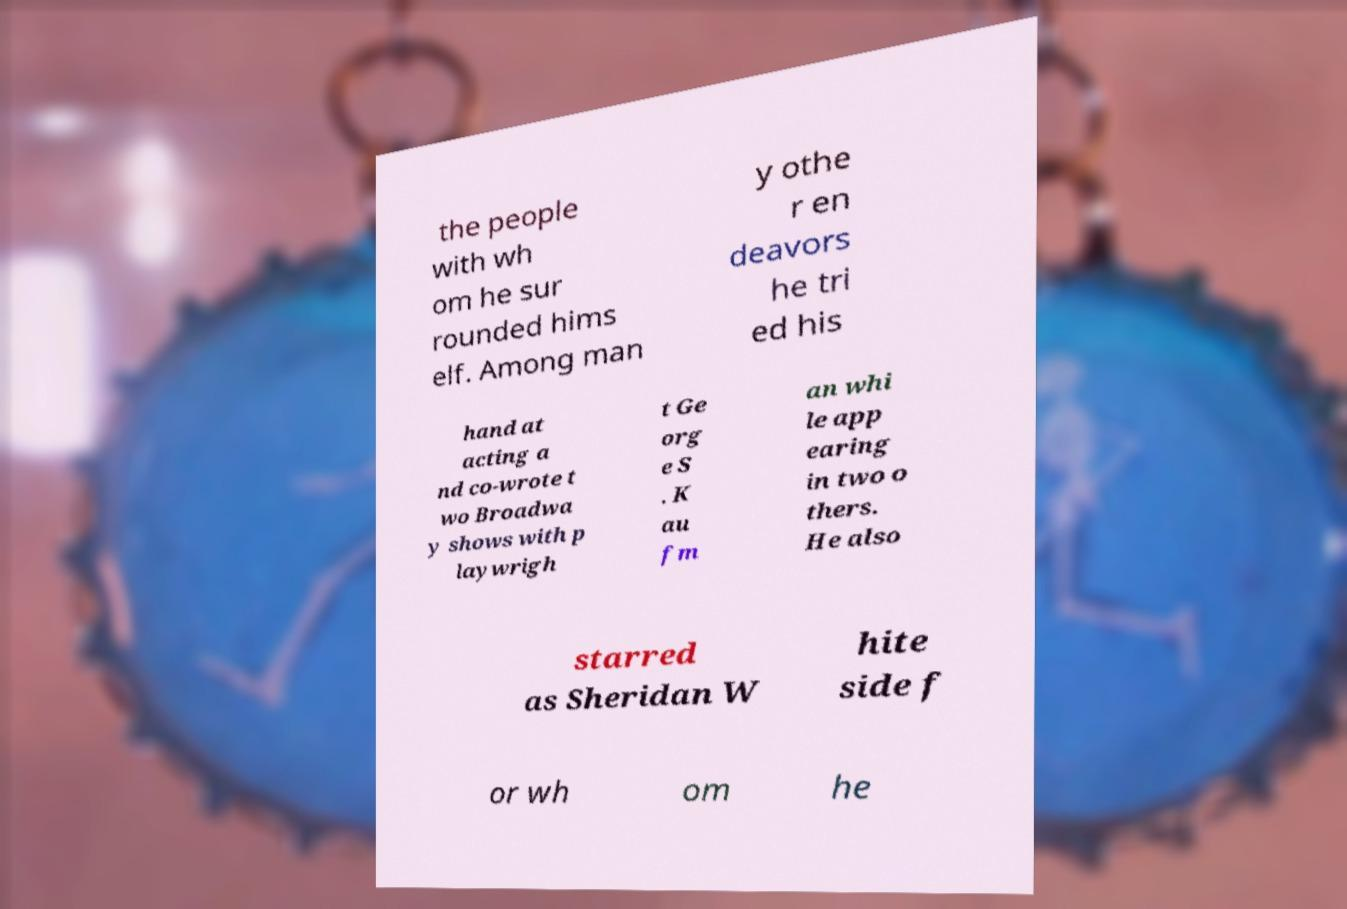What messages or text are displayed in this image? I need them in a readable, typed format. the people with wh om he sur rounded hims elf. Among man y othe r en deavors he tri ed his hand at acting a nd co-wrote t wo Broadwa y shows with p laywrigh t Ge org e S . K au fm an whi le app earing in two o thers. He also starred as Sheridan W hite side f or wh om he 